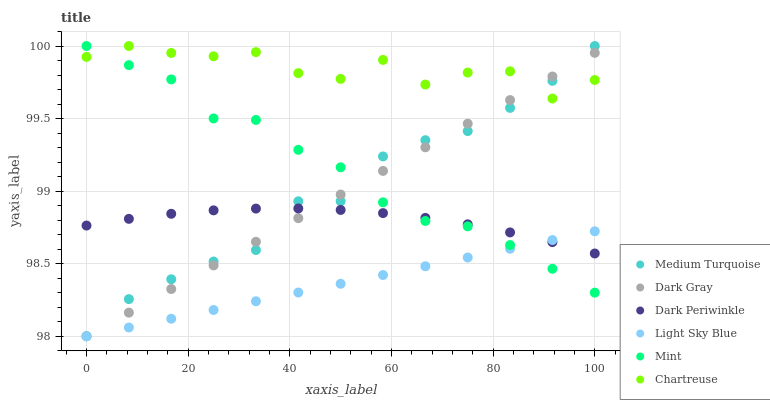Does Light Sky Blue have the minimum area under the curve?
Answer yes or no. Yes. Does Chartreuse have the maximum area under the curve?
Answer yes or no. Yes. Does Chartreuse have the minimum area under the curve?
Answer yes or no. No. Does Light Sky Blue have the maximum area under the curve?
Answer yes or no. No. Is Dark Gray the smoothest?
Answer yes or no. Yes. Is Chartreuse the roughest?
Answer yes or no. Yes. Is Light Sky Blue the smoothest?
Answer yes or no. No. Is Light Sky Blue the roughest?
Answer yes or no. No. Does Dark Gray have the lowest value?
Answer yes or no. Yes. Does Chartreuse have the lowest value?
Answer yes or no. No. Does Mint have the highest value?
Answer yes or no. Yes. Does Light Sky Blue have the highest value?
Answer yes or no. No. Is Dark Periwinkle less than Chartreuse?
Answer yes or no. Yes. Is Chartreuse greater than Dark Periwinkle?
Answer yes or no. Yes. Does Mint intersect Chartreuse?
Answer yes or no. Yes. Is Mint less than Chartreuse?
Answer yes or no. No. Is Mint greater than Chartreuse?
Answer yes or no. No. Does Dark Periwinkle intersect Chartreuse?
Answer yes or no. No. 